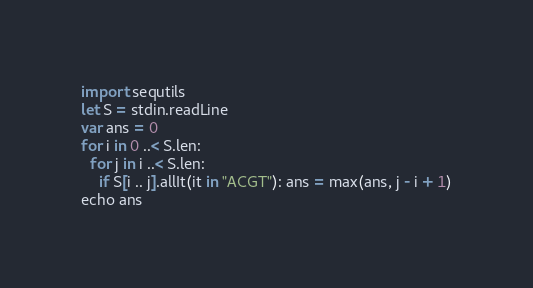<code> <loc_0><loc_0><loc_500><loc_500><_Nim_>import sequtils
let S = stdin.readLine
var ans = 0
for i in 0 ..< S.len:
  for j in i ..< S.len:
    if S[i .. j].allIt(it in "ACGT"): ans = max(ans, j - i + 1)
echo ans</code> 